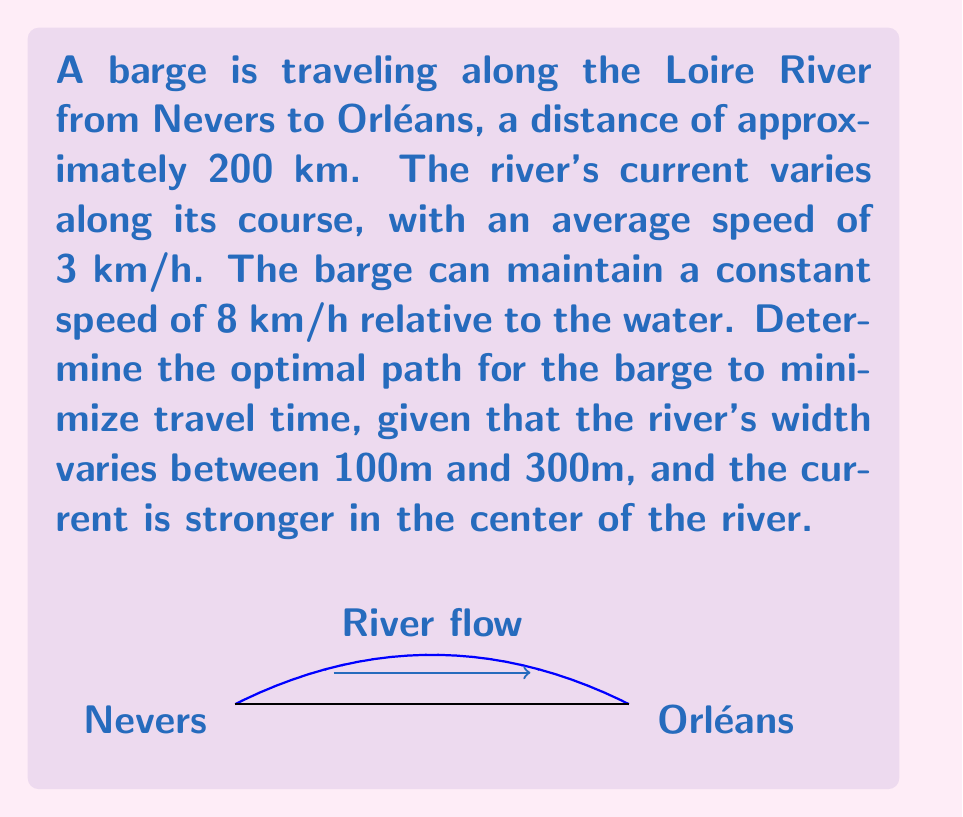Can you solve this math problem? To solve this problem, we need to consider the vector-valued function that describes the barge's motion. Let's approach this step-by-step:

1) First, we need to set up a coordinate system. Let's say the x-axis is along the river's length, and the y-axis is across its width.

2) The barge's velocity vector $\vec{v}$ can be decomposed into two components:
   $\vec{v} = \vec{v}_w + \vec{v}_c$
   where $\vec{v}_w$ is the barge's velocity relative to water, and $\vec{v}_c$ is the current's velocity.

3) The current's velocity varies across the river's width. We can model this with a parabolic function:
   $\vec{v}_c(y) = 3(1 - (\frac{2y}{w})^2)\hat{i}$
   where $w$ is the river's width at any given point.

4) The barge's velocity relative to water is constant at 8 km/h. We can express this as:
   $\vec{v}_w = 8(\cos\theta\hat{i} + \sin\theta\hat{j})$
   where $\theta$ is the angle between the barge's direction and the river's direction.

5) The total velocity is thus:
   $\vec{v} = (8\cos\theta + 3(1 - (\frac{2y}{w})^2))\hat{i} + 8\sin\theta\hat{j}$

6) To minimize travel time, we need to maximize the x-component of this velocity. This occurs when:
   $\frac{\partial v_x}{\partial y} = 0$ and $\frac{\partial v_x}{\partial \theta} = 0$

7) Solving these equations gives us:
   $y = 0$ (the center of the river) and $\theta = 0$ (parallel to the river)

8) Therefore, the optimal path is for the barge to travel in the center of the river, parallel to its banks.

9) The travel time can be calculated as:
   $t = \frac{200}{8 + 3} = 18.18$ hours
Answer: The optimal path is along the center of the river, parallel to its banks. Travel time: 18.18 hours. 